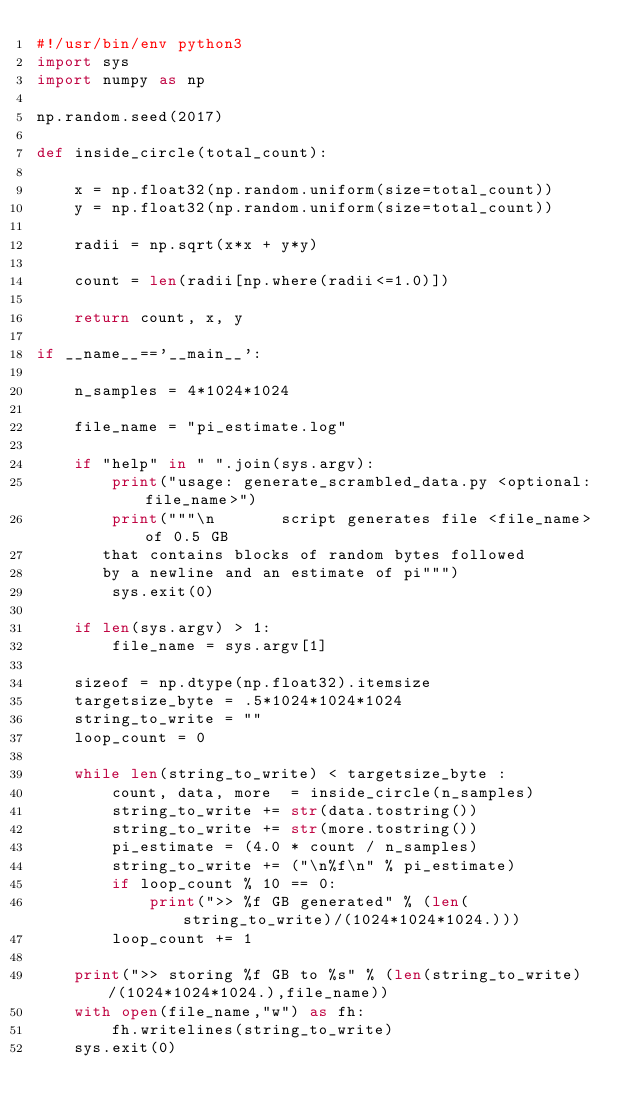<code> <loc_0><loc_0><loc_500><loc_500><_Python_>#!/usr/bin/env python3
import sys
import numpy as np

np.random.seed(2017)

def inside_circle(total_count):

    x = np.float32(np.random.uniform(size=total_count))
    y = np.float32(np.random.uniform(size=total_count))

    radii = np.sqrt(x*x + y*y)

    count = len(radii[np.where(radii<=1.0)])

    return count, x, y

if __name__=='__main__':

    n_samples = 4*1024*1024

    file_name = "pi_estimate.log"

    if "help" in " ".join(sys.argv):
        print("usage: generate_scrambled_data.py <optional:file_name>")
        print("""\n       script generates file <file_name> of 0.5 GB
       that contains blocks of random bytes followed
       by a newline and an estimate of pi""")
        sys.exit(0)

    if len(sys.argv) > 1:
        file_name = sys.argv[1]

    sizeof = np.dtype(np.float32).itemsize
    targetsize_byte = .5*1024*1024*1024
    string_to_write = ""
    loop_count = 0

    while len(string_to_write) < targetsize_byte :
        count, data, more  = inside_circle(n_samples)
        string_to_write += str(data.tostring())
        string_to_write += str(more.tostring())
        pi_estimate = (4.0 * count / n_samples)
        string_to_write += ("\n%f\n" % pi_estimate)
        if loop_count % 10 == 0:
            print(">> %f GB generated" % (len(string_to_write)/(1024*1024*1024.)))
        loop_count += 1

    print(">> storing %f GB to %s" % (len(string_to_write)/(1024*1024*1024.),file_name))
    with open(file_name,"w") as fh:
        fh.writelines(string_to_write)
    sys.exit(0)
</code> 